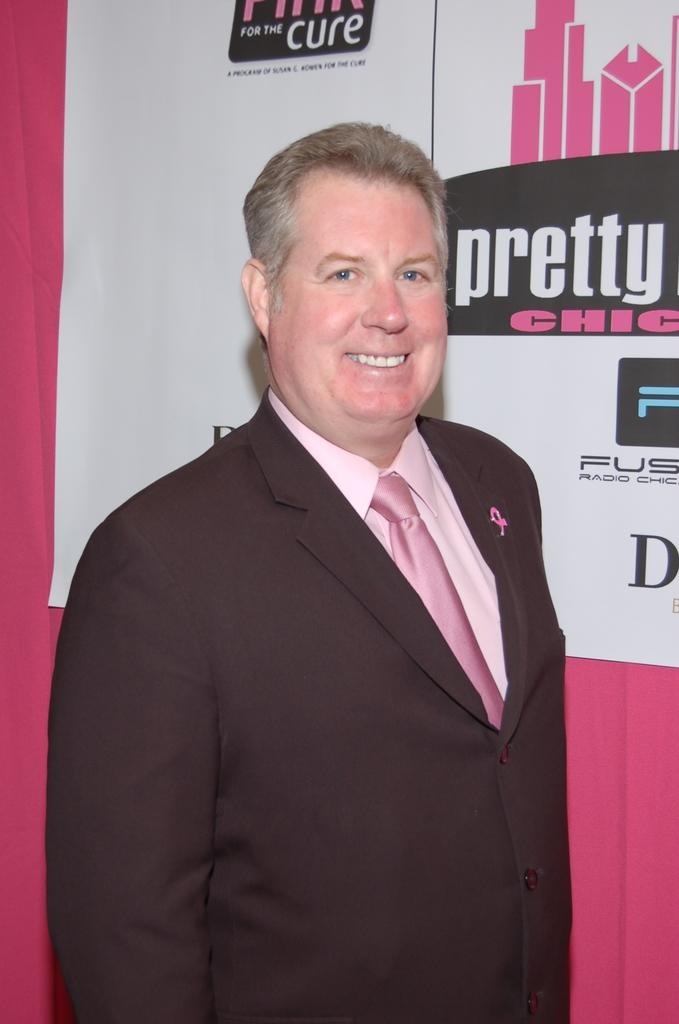<image>
Offer a succinct explanation of the picture presented. A pink suit wearing man wit hthe logo for pretty for the cure in the background. 